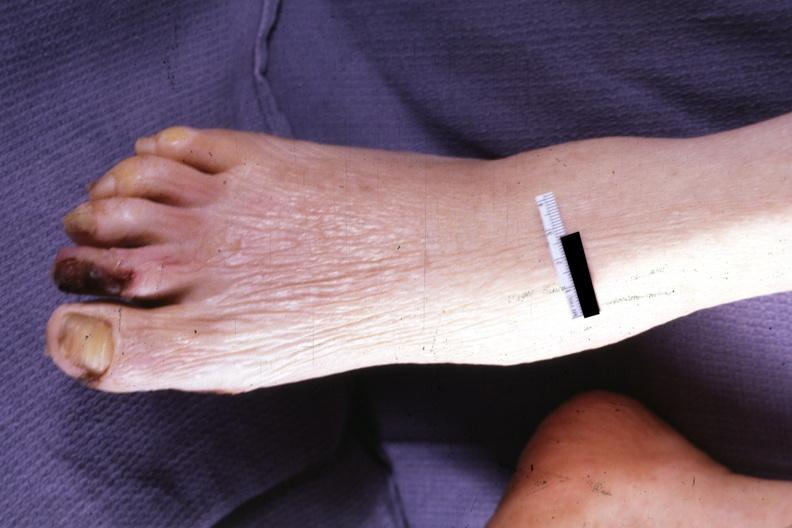what are present?
Answer the question using a single word or phrase. Extremities 